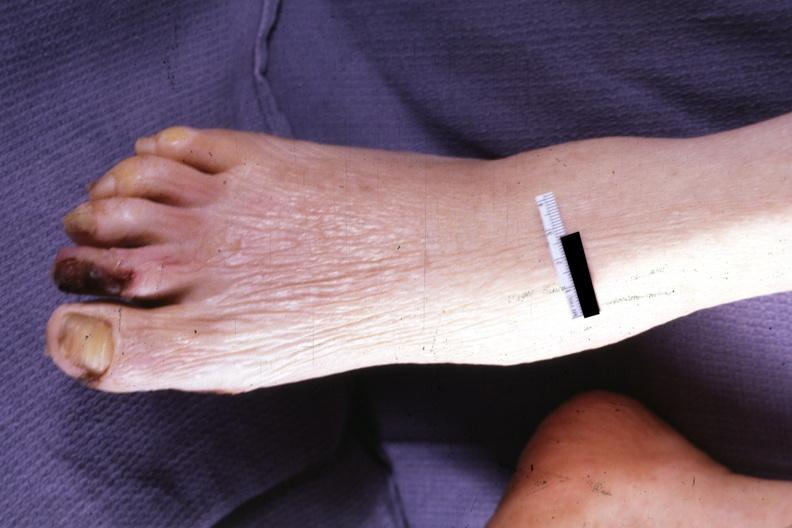what are present?
Answer the question using a single word or phrase. Extremities 